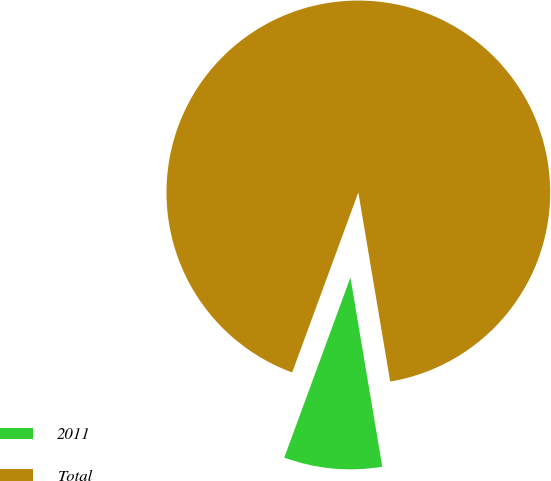Convert chart. <chart><loc_0><loc_0><loc_500><loc_500><pie_chart><fcel>2011<fcel>Total<nl><fcel>8.26%<fcel>91.74%<nl></chart> 